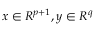<formula> <loc_0><loc_0><loc_500><loc_500>x \in R ^ { p + 1 } , y \in R ^ { q }</formula> 